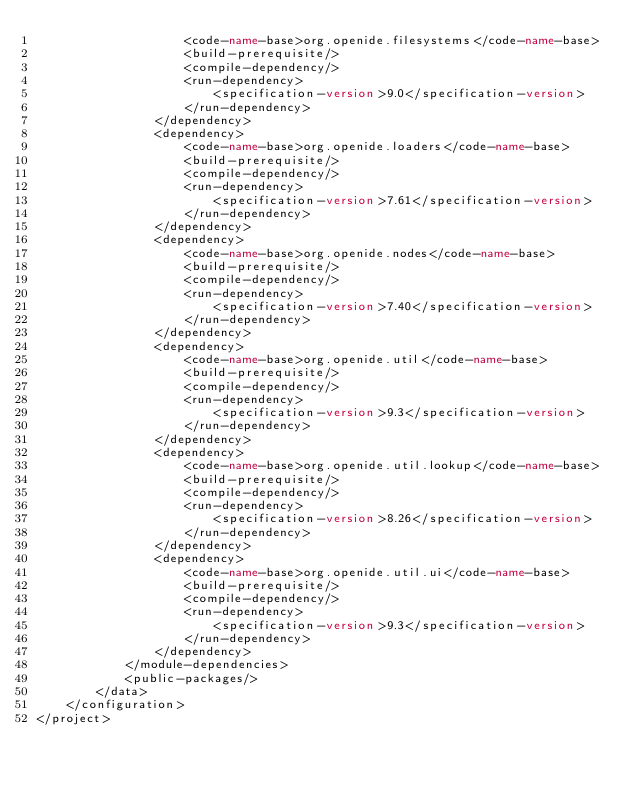Convert code to text. <code><loc_0><loc_0><loc_500><loc_500><_XML_>                    <code-name-base>org.openide.filesystems</code-name-base>
                    <build-prerequisite/>
                    <compile-dependency/>
                    <run-dependency>
                        <specification-version>9.0</specification-version>
                    </run-dependency>
                </dependency>
                <dependency>
                    <code-name-base>org.openide.loaders</code-name-base>
                    <build-prerequisite/>
                    <compile-dependency/>
                    <run-dependency>
                        <specification-version>7.61</specification-version>
                    </run-dependency>
                </dependency>
                <dependency>
                    <code-name-base>org.openide.nodes</code-name-base>
                    <build-prerequisite/>
                    <compile-dependency/>
                    <run-dependency>
                        <specification-version>7.40</specification-version>
                    </run-dependency>
                </dependency>
                <dependency>
                    <code-name-base>org.openide.util</code-name-base>
                    <build-prerequisite/>
                    <compile-dependency/>
                    <run-dependency>
                        <specification-version>9.3</specification-version>
                    </run-dependency>
                </dependency>
                <dependency>
                    <code-name-base>org.openide.util.lookup</code-name-base>
                    <build-prerequisite/>
                    <compile-dependency/>
                    <run-dependency>
                        <specification-version>8.26</specification-version>
                    </run-dependency>
                </dependency>
                <dependency>
                    <code-name-base>org.openide.util.ui</code-name-base>
                    <build-prerequisite/>
                    <compile-dependency/>
                    <run-dependency>
                        <specification-version>9.3</specification-version>
                    </run-dependency>
                </dependency>
            </module-dependencies>
            <public-packages/>
        </data>
    </configuration>
</project>
</code> 